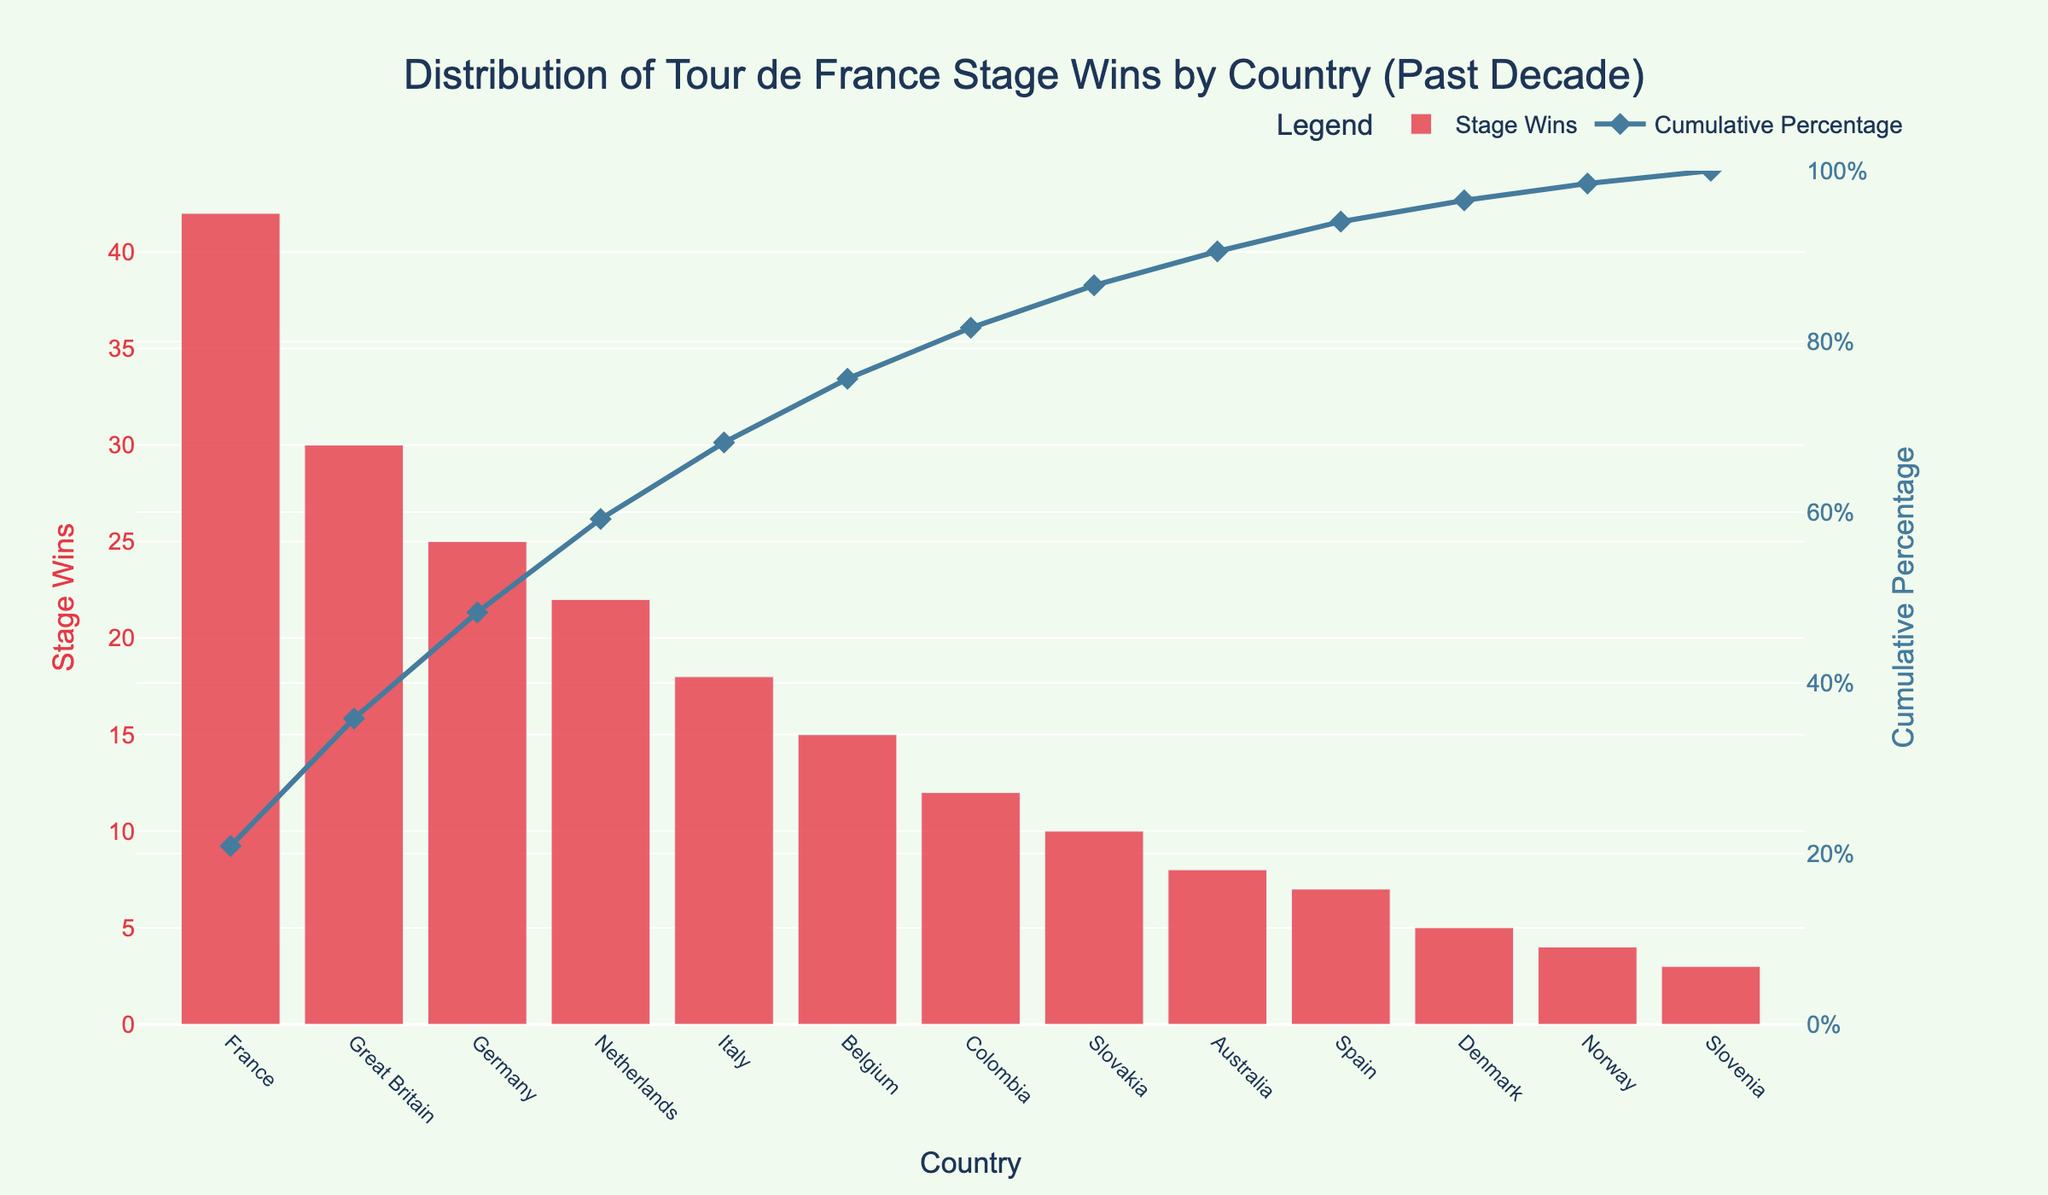Which country has the highest number of stage wins? France has the highest number of stage wins with 42, as observed from the tallest bar at the left-most position in the chart.
Answer: France Which country comes second in terms of stage wins? Great Britain ranks second with 30 stage wins, as indicated by the second tallest bar in the chart next to France.
Answer: Great Britain What is the cumulative percentage of stage wins after including Great Britain? Adding Great Britain’s 30 stage wins to France’s 42 gives a cumulative sum of 72 stage wins. The total stage wins are 201, so the cumulative percentage is (72/201)*100 = 35.82%.
Answer: 35.82% How many stage wins do Germany and Italy have combined? Germany has 25 stage wins and Italy has 18, combining for a total of 25 + 18 = 43 stage wins.
Answer: 43 Which country has exactly 8 stage wins? Australia has exactly 8 stage wins as indicated by the corresponding bar’s height.
Answer: Australia What is the cumulative percentage of stage wins represented by the top three countries? The top three countries are France (42), Great Britain (30), and Germany (25). Adding these, 42 + 30 + 25 = 97. The total stage wins are 201, so the cumulative percentage is (97/201)*100 = 48.26%.
Answer: 48.26% What color represents the bars indicating the number of stage wins? The bars are colored in a shade of red, as observed from the dominant color of the bar chart.
Answer: Red What is the approximate cumulative percentage after Slovakia? Slovakia, tenth in the list with 10 stage wins, adds up to a cumulative sum of 177 stage wins. The cumulative percentage is (177/201)*100 ≈ 88.06%.
Answer: 88.06% How many countries have stage wins fewer than 10 but more than or equal to 5? Denmark (5), Norway (4), and Slovenia (3) each have fewer than 10 stage wins. However, only Denmark qualifies with stage wins greater than or equal to 5: 5.
Answer: 1 By how much does Italy surpass Belgium in stage wins? Italy has 18 stage wins whereas Belgium has 15. The difference between Italy and Belgium’s stage wins is 18 - 15 = 3.
Answer: 3 